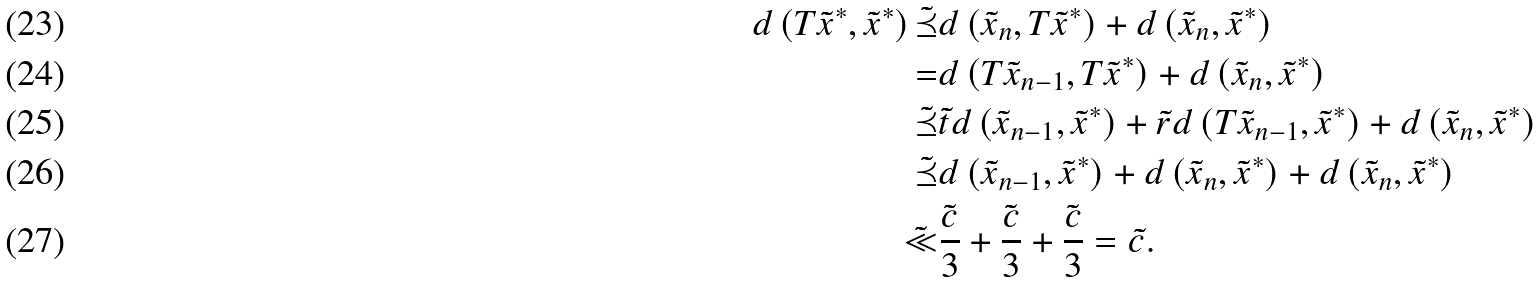<formula> <loc_0><loc_0><loc_500><loc_500>d \left ( T \tilde { x } ^ { * } , \tilde { x } ^ { * } \right ) \tilde { \preceq } & d \left ( \tilde { x } _ { n } , T \tilde { x } ^ { * } \right ) + d \left ( \tilde { x } _ { n } , \tilde { x } ^ { * } \right ) \\ = & d \left ( T \tilde { x } _ { n - 1 } , T \tilde { x } ^ { * } \right ) + d \left ( \tilde { x } _ { n } , \tilde { x } ^ { * } \right ) \\ \tilde { \preceq } & \tilde { t } d \left ( \tilde { x } _ { n - 1 } , \tilde { x } ^ { * } \right ) + \tilde { r } d \left ( T \tilde { x } _ { n - 1 } , \tilde { x } ^ { * } \right ) + d \left ( \tilde { x } _ { n } , \tilde { x } ^ { * } \right ) \\ \tilde { \preceq } & d \left ( \tilde { x } _ { n - 1 } , \tilde { x } ^ { * } \right ) + d \left ( \tilde { x } _ { n } , \tilde { x } ^ { * } \right ) + d \left ( \tilde { x } _ { n } , \tilde { x } ^ { * } \right ) \\ \tilde { \ll } & \tilde { \frac { c } { 3 } } + \tilde { \frac { c } { 3 } } + \tilde { \frac { c } { 3 } } = \tilde { c } .</formula> 